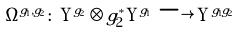Convert formula to latex. <formula><loc_0><loc_0><loc_500><loc_500>\Omega ^ { g _ { 1 } , g _ { 2 } } \colon \, \Upsilon ^ { g _ { 2 } } \otimes g _ { 2 } ^ { * } \Upsilon ^ { g _ { 1 } } \, \longrightarrow \, \Upsilon ^ { g _ { 1 } g _ { 2 } }</formula> 